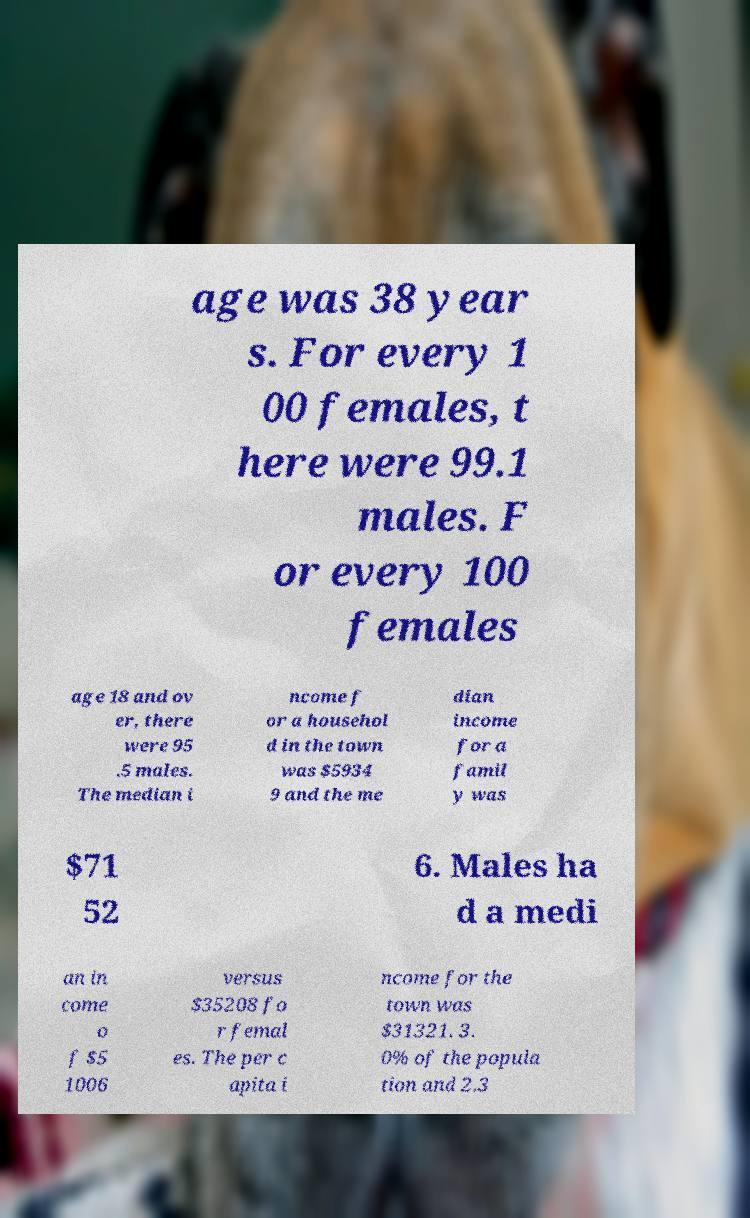Could you extract and type out the text from this image? age was 38 year s. For every 1 00 females, t here were 99.1 males. F or every 100 females age 18 and ov er, there were 95 .5 males. The median i ncome f or a househol d in the town was $5934 9 and the me dian income for a famil y was $71 52 6. Males ha d a medi an in come o f $5 1006 versus $35208 fo r femal es. The per c apita i ncome for the town was $31321. 3. 0% of the popula tion and 2.3 